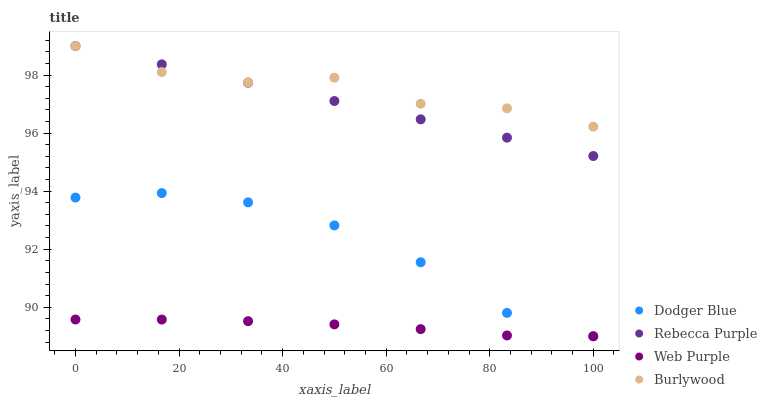Does Web Purple have the minimum area under the curve?
Answer yes or no. Yes. Does Burlywood have the maximum area under the curve?
Answer yes or no. Yes. Does Dodger Blue have the minimum area under the curve?
Answer yes or no. No. Does Dodger Blue have the maximum area under the curve?
Answer yes or no. No. Is Rebecca Purple the smoothest?
Answer yes or no. Yes. Is Burlywood the roughest?
Answer yes or no. Yes. Is Web Purple the smoothest?
Answer yes or no. No. Is Web Purple the roughest?
Answer yes or no. No. Does Web Purple have the lowest value?
Answer yes or no. Yes. Does Rebecca Purple have the lowest value?
Answer yes or no. No. Does Rebecca Purple have the highest value?
Answer yes or no. Yes. Does Dodger Blue have the highest value?
Answer yes or no. No. Is Web Purple less than Rebecca Purple?
Answer yes or no. Yes. Is Rebecca Purple greater than Web Purple?
Answer yes or no. Yes. Does Web Purple intersect Dodger Blue?
Answer yes or no. Yes. Is Web Purple less than Dodger Blue?
Answer yes or no. No. Is Web Purple greater than Dodger Blue?
Answer yes or no. No. Does Web Purple intersect Rebecca Purple?
Answer yes or no. No. 